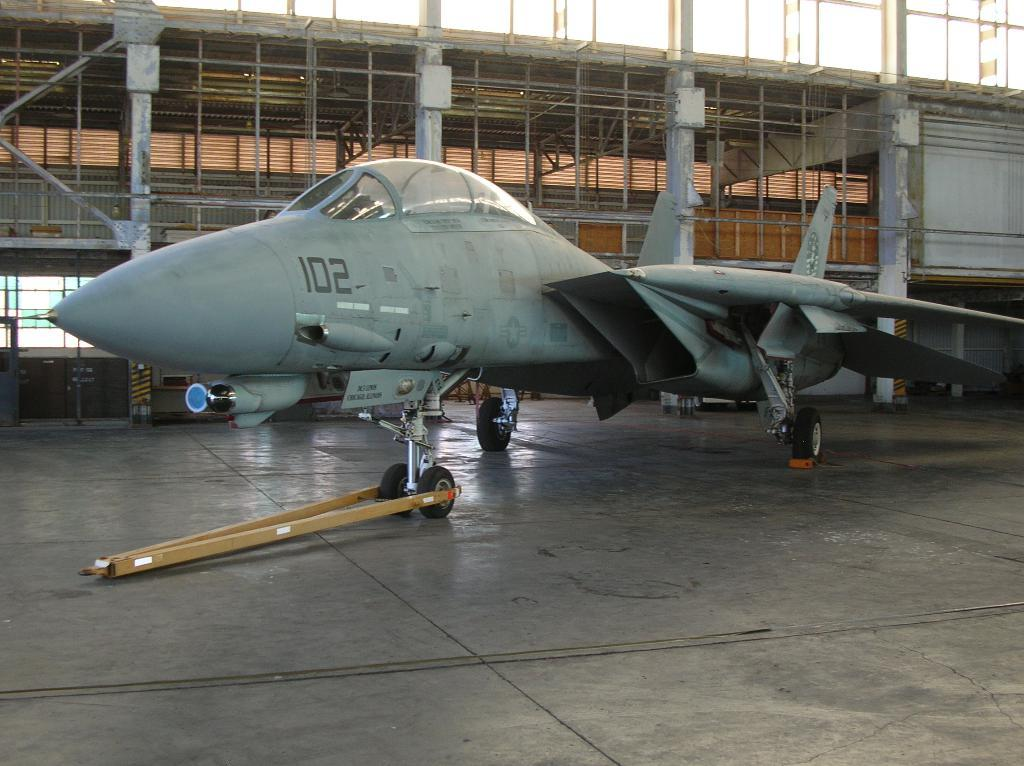What type of vehicle is on the floor in the image? There is a military jet on the floor in the image. What type of structure can be seen in the image? There are iron grills in the image. What else is present in the image besides the military jet and iron grills? There are poles in the image. What can be seen in the background of the image? The sky is visible in the image. Where is the playground located in the image? There is no playground present in the image. Can you see any volcanoes in the image? There are no volcanoes present in the image. 